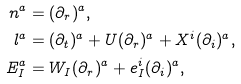Convert formula to latex. <formula><loc_0><loc_0><loc_500><loc_500>n ^ { a } & = ( \partial _ { r } ) ^ { a } , \\ l ^ { a } & = ( \partial _ { t } ) ^ { a } + U ( \partial _ { r } ) ^ { a } + X ^ { i } ( \partial _ { i } ) ^ { a } , \\ E _ { I } ^ { a } & = W _ { I } ( \partial _ { r } ) ^ { a } + e _ { I } ^ { i } ( \partial _ { i } ) ^ { a } ,</formula> 